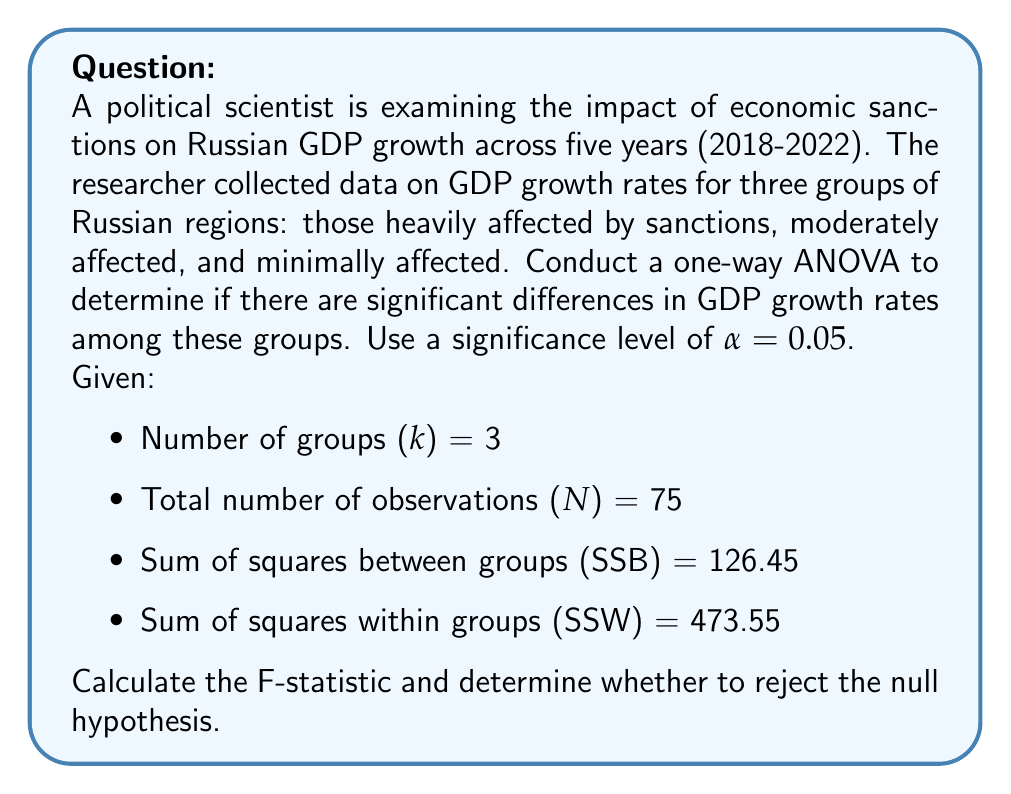Teach me how to tackle this problem. To conduct a one-way ANOVA and determine if there are significant differences in GDP growth rates among the three groups of Russian regions, we'll follow these steps:

1. Calculate degrees of freedom:
   - Between groups: $df_B = k - 1 = 3 - 1 = 2$
   - Within groups: $df_W = N - k = 75 - 3 = 72$
   - Total: $df_T = N - 1 = 75 - 1 = 74$

2. Calculate Mean Square Between (MSB) and Mean Square Within (MSW):
   $$ MSB = \frac{SSB}{df_B} = \frac{126.45}{2} = 63.225 $$
   $$ MSW = \frac{SSW}{df_W} = \frac{473.55}{72} = 6.577083 $$

3. Calculate the F-statistic:
   $$ F = \frac{MSB}{MSW} = \frac{63.225}{6.577083} = 9.613 $$

4. Determine the critical F-value:
   For α = 0.05, $df_B = 2$, and $df_W = 72$, the critical F-value is approximately 3.124 (obtained from an F-distribution table or calculator).

5. Compare the calculated F-statistic to the critical F-value:
   Since 9.613 > 3.124, we reject the null hypothesis.

6. Interpret the results:
   There is strong evidence to suggest that there are significant differences in GDP growth rates among the three groups of Russian regions affected by economic sanctions (p < 0.05).
Answer: F-statistic = 9.613
Reject the null hypothesis. There are significant differences in GDP growth rates among the groups of Russian regions affected by economic sanctions (p < 0.05). 